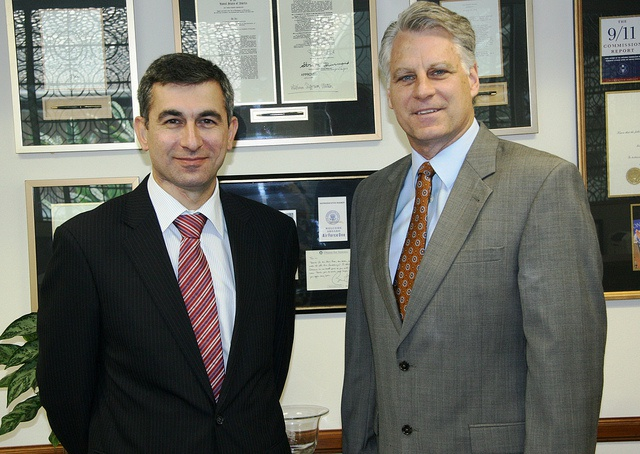Describe the objects in this image and their specific colors. I can see people in darkgray, gray, and black tones, people in darkgray, black, lightgray, gray, and tan tones, tie in darkgray, brown, and maroon tones, and tie in darkgray, maroon, brown, and gray tones in this image. 